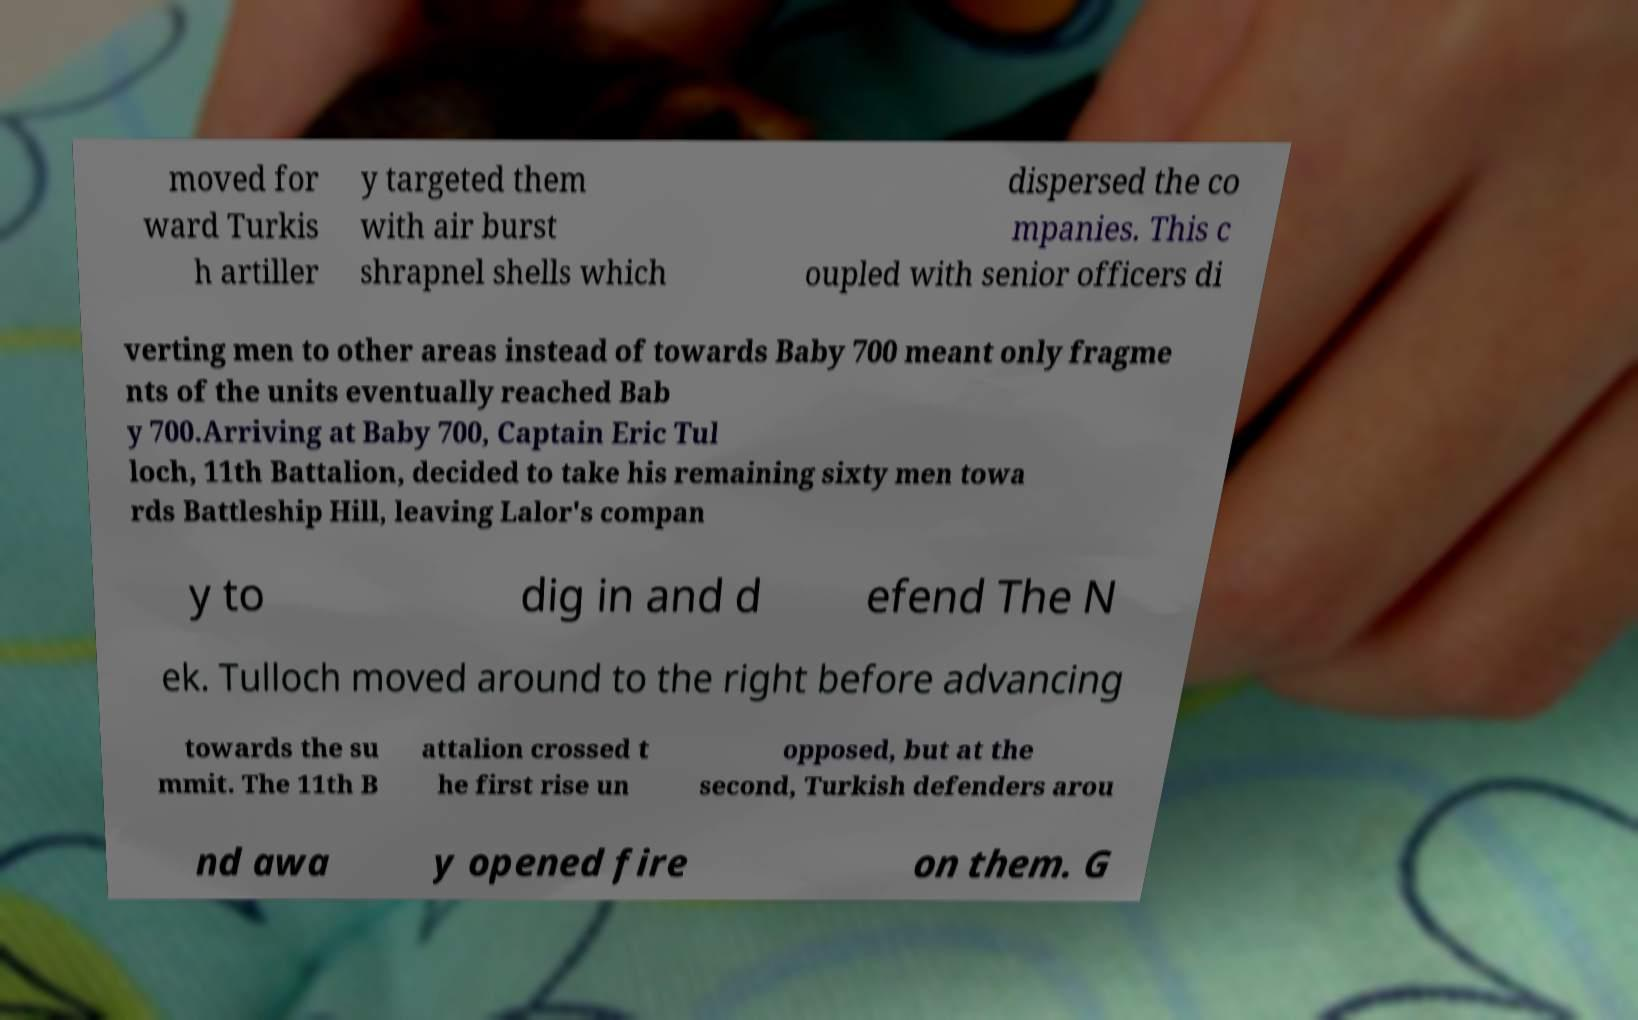I need the written content from this picture converted into text. Can you do that? moved for ward Turkis h artiller y targeted them with air burst shrapnel shells which dispersed the co mpanies. This c oupled with senior officers di verting men to other areas instead of towards Baby 700 meant only fragme nts of the units eventually reached Bab y 700.Arriving at Baby 700, Captain Eric Tul loch, 11th Battalion, decided to take his remaining sixty men towa rds Battleship Hill, leaving Lalor's compan y to dig in and d efend The N ek. Tulloch moved around to the right before advancing towards the su mmit. The 11th B attalion crossed t he first rise un opposed, but at the second, Turkish defenders arou nd awa y opened fire on them. G 